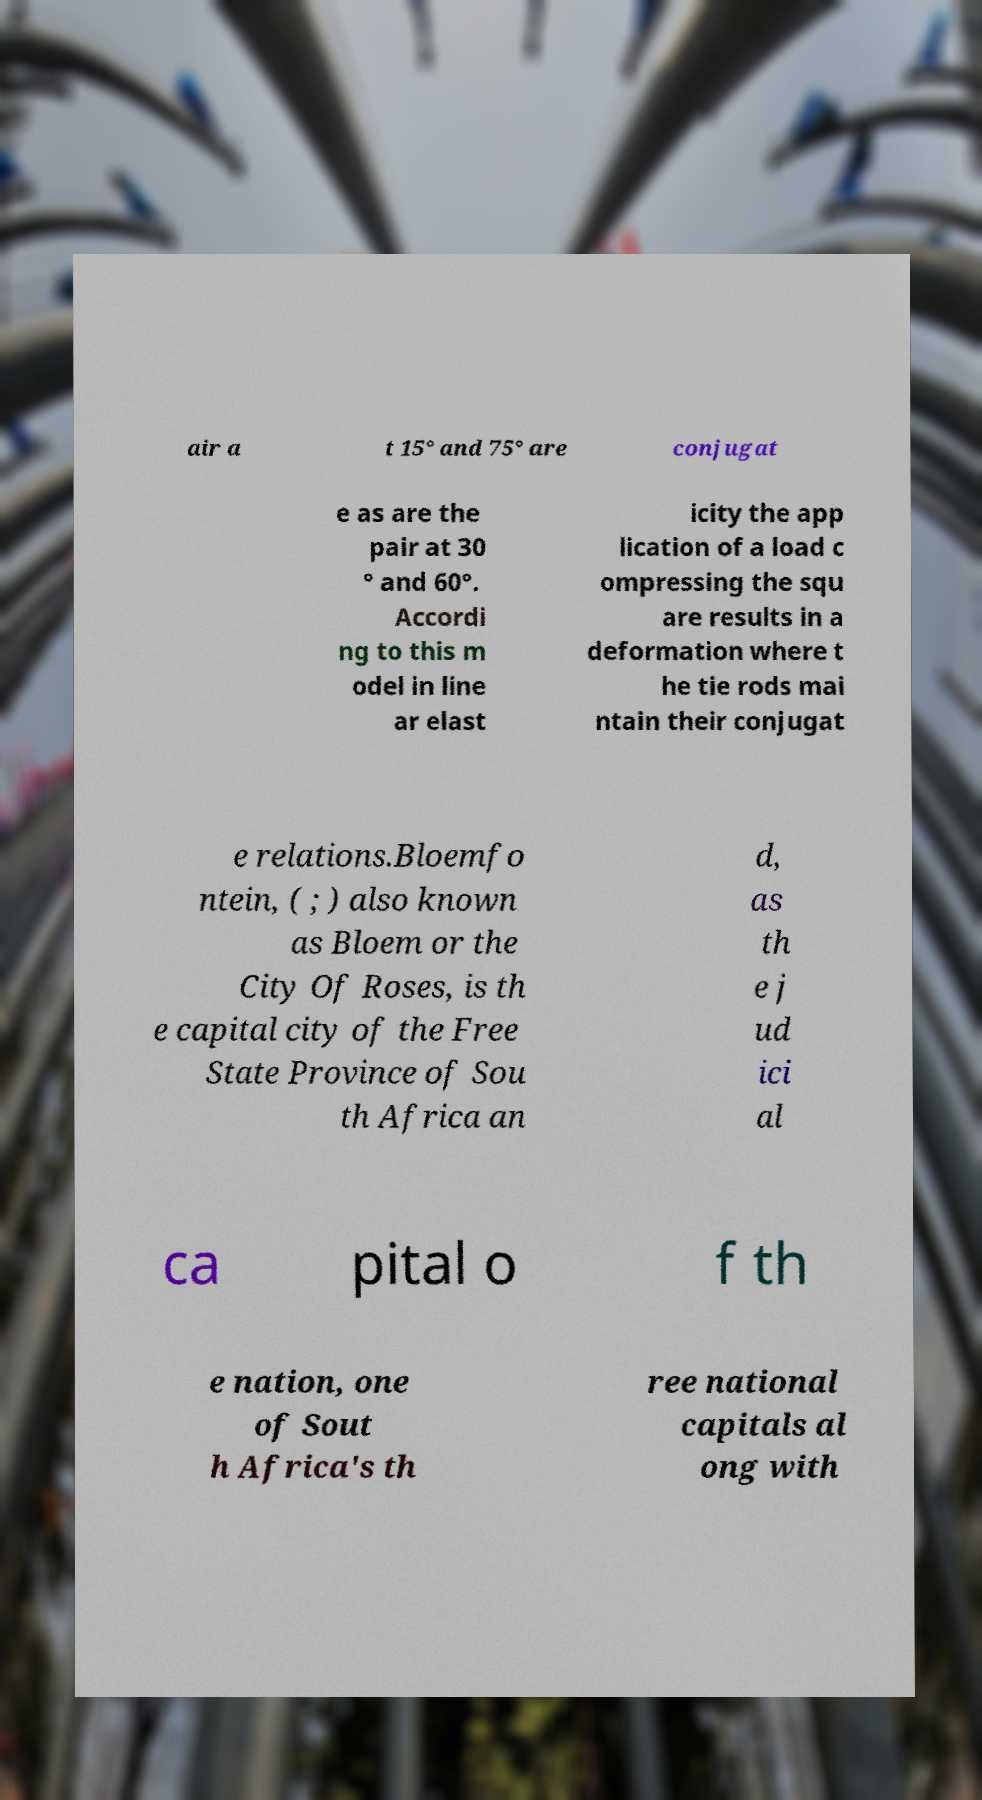Please read and relay the text visible in this image. What does it say? air a t 15° and 75° are conjugat e as are the pair at 30 ° and 60°. Accordi ng to this m odel in line ar elast icity the app lication of a load c ompressing the squ are results in a deformation where t he tie rods mai ntain their conjugat e relations.Bloemfo ntein, ( ; ) also known as Bloem or the City Of Roses, is th e capital city of the Free State Province of Sou th Africa an d, as th e j ud ici al ca pital o f th e nation, one of Sout h Africa's th ree national capitals al ong with 